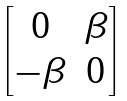Convert formula to latex. <formula><loc_0><loc_0><loc_500><loc_500>\begin{bmatrix} 0 & \beta \\ - \beta & 0 \end{bmatrix}</formula> 